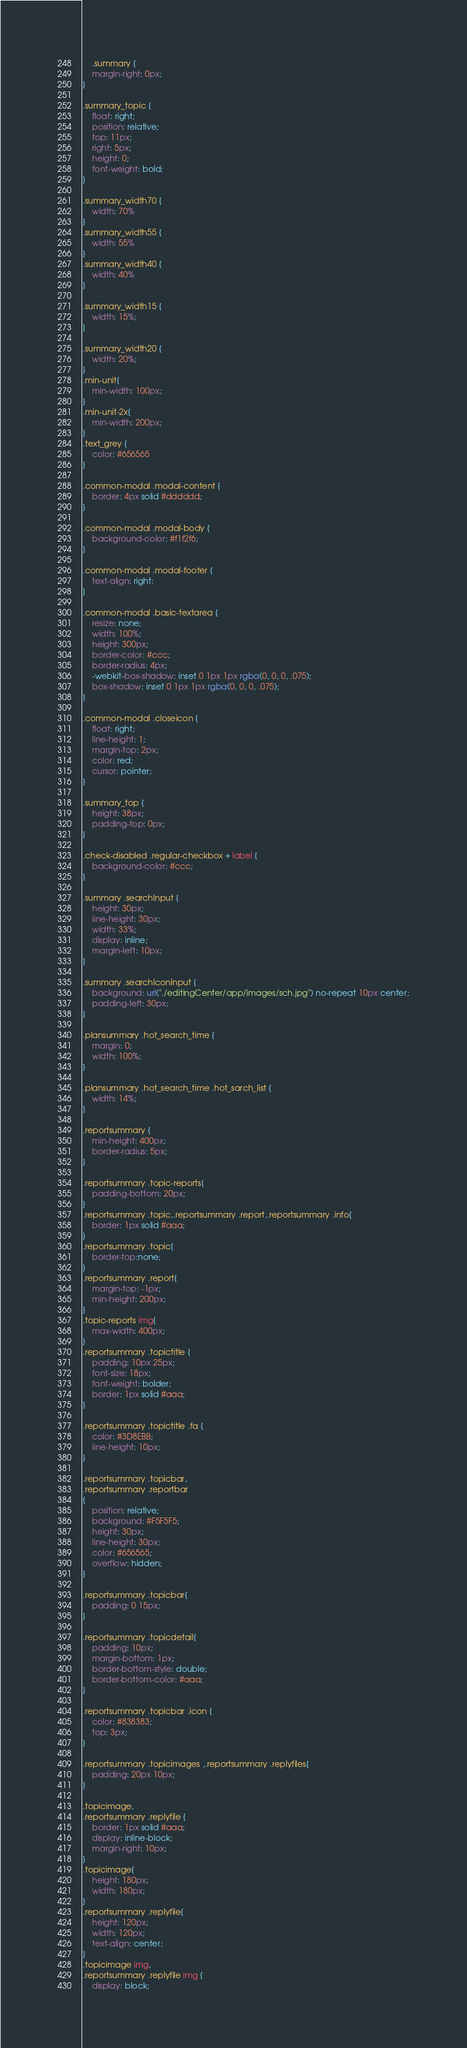<code> <loc_0><loc_0><loc_500><loc_500><_CSS_>    .summary {
    margin-right: 0px;
}

.summary_topic {
    float: right;
    position: relative;
    top: 11px;
    right: 5px;
    height: 0;
    font-weight: bold;
}

.summary_width70 {
    width: 70%
}
.summary_width55 {
    width: 55%
}
.summary_width40 {
    width: 40%
}

.summary_width15 {
    width: 15%;
}

.summary_width20 {
    width: 20%;
}
.min-unit{
    min-width: 100px;
}
.min-unit-2x{
    min-width: 200px;
}
.text_grey {
    color: #656565
}

.common-modal .modal-content {
    border: 4px solid #dddddd;
}

.common-modal .modal-body {
    background-color: #f1f2f6;
}

.common-modal .modal-footer {
    text-align: right;
}

.common-modal .basic-textarea {
    resize: none;
    width: 100%;
    height: 300px;
    border-color: #ccc;
    border-radius: 4px;
    -webkit-box-shadow: inset 0 1px 1px rgba(0, 0, 0, .075);
    box-shadow: inset 0 1px 1px rgba(0, 0, 0, .075);
}

.common-modal .closeicon {
    float: right;
    line-height: 1;
    margin-top: 2px;
    color: red;
    cursor: pointer;
}

.summary_top {
    height: 38px;
    padding-top: 0px;
}

.check-disabled .regular-checkbox + label {
    background-color: #ccc;
}

.summary .searchInput {
    height: 30px;
    line-height: 30px;
    width: 33%;
    display: inline;
    margin-left: 10px;
}

.summary .searchIconInput {
    background: url("./editingCenter/app/images/sch.jpg") no-repeat 10px center;
    padding-left: 30px;
}

.plansummary .hot_search_time {
    margin: 0;
    width: 100%;
}

.plansummary .hot_search_time .hot_sarch_list {
    width: 14%;
}

.reportsummary {
    min-height: 400px;
    border-radius: 5px;
}

.reportsummary .topic-reports{
    padding-bottom: 20px;
}
.reportsummary .topic,.reportsummary .report,.reportsummary .info{
    border: 1px solid #aaa;
}
.reportsummary .topic{
    border-top:none;
}
.reportsummary .report{
    margin-top: -1px;
    min-height: 200px;
}
.topic-reports img{
    max-width: 400px;
}
.reportsummary .topictitle {
    padding: 10px 25px;
    font-size: 18px;
    font-weight: bolder;
    border: 1px solid #aaa; 
}

.reportsummary .topictitle .fa {
    color: #3D8EBB;
    line-height: 10px;
}

.reportsummary .topicbar,
.reportsummary .reportbar
{
    position: relative;
    background: #F5F5F5;
    height: 30px;
    line-height: 30px;
    color: #656565;
    overflow: hidden;
}

.reportsummary .topicbar{
    padding: 0 15px;
}

.reportsummary .topicdetail{
    padding: 10px;
    margin-bottom: 1px; 
    border-bottom-style: double;
    border-bottom-color: #aaa;
}

.reportsummary .topicbar .icon {
    color: #838383;
    top: 3px;
}

.reportsummary .topicimages ,.reportsummary .replyfiles{ 
    padding: 20px 10px;
}

.topicimage,
.reportsummary .replyfile { 
    border: 1px solid #aaa; 
    display: inline-block;
    margin-right: 10px;
}
.topicimage{
    height: 180px;
    width: 180px;
}
.reportsummary .replyfile{ 
    height: 120px;
    width: 120px; 
    text-align: center;
} 
.topicimage img,
.reportsummary .replyfile img {
    display: block;</code> 